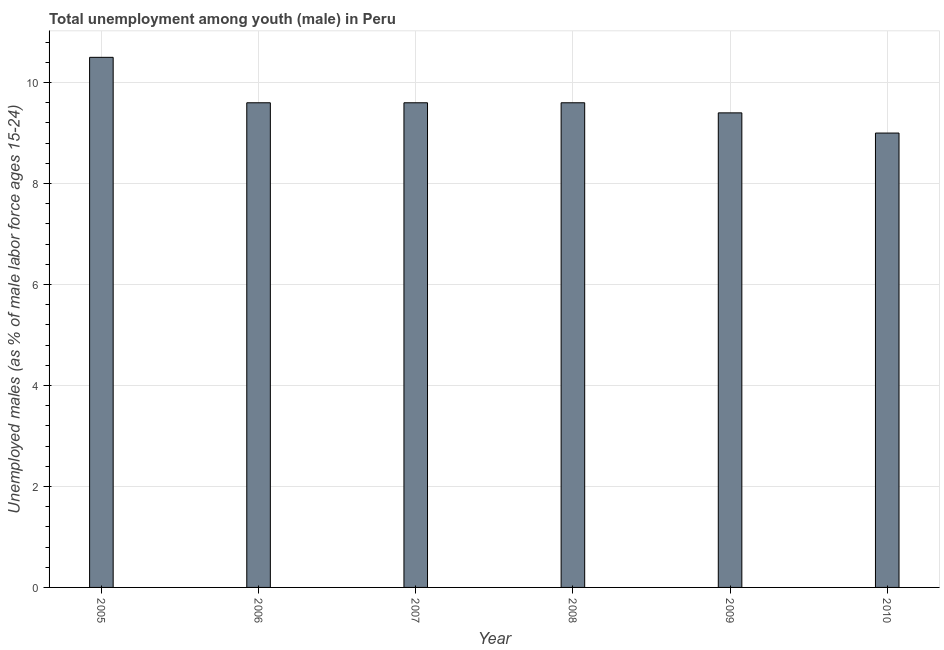Does the graph contain any zero values?
Give a very brief answer. No. What is the title of the graph?
Provide a short and direct response. Total unemployment among youth (male) in Peru. What is the label or title of the X-axis?
Ensure brevity in your answer.  Year. What is the label or title of the Y-axis?
Provide a short and direct response. Unemployed males (as % of male labor force ages 15-24). What is the unemployed male youth population in 2008?
Ensure brevity in your answer.  9.6. What is the sum of the unemployed male youth population?
Keep it short and to the point. 57.7. What is the difference between the unemployed male youth population in 2009 and 2010?
Give a very brief answer. 0.4. What is the average unemployed male youth population per year?
Your answer should be very brief. 9.62. What is the median unemployed male youth population?
Offer a very short reply. 9.6. In how many years, is the unemployed male youth population greater than 7.6 %?
Keep it short and to the point. 6. Do a majority of the years between 2008 and 2010 (inclusive) have unemployed male youth population greater than 2.4 %?
Your response must be concise. Yes. What is the ratio of the unemployed male youth population in 2005 to that in 2009?
Offer a terse response. 1.12. Is the difference between the unemployed male youth population in 2005 and 2009 greater than the difference between any two years?
Provide a short and direct response. No. Is the sum of the unemployed male youth population in 2005 and 2008 greater than the maximum unemployed male youth population across all years?
Offer a terse response. Yes. In how many years, is the unemployed male youth population greater than the average unemployed male youth population taken over all years?
Offer a very short reply. 1. How many bars are there?
Keep it short and to the point. 6. How many years are there in the graph?
Your answer should be very brief. 6. What is the difference between two consecutive major ticks on the Y-axis?
Make the answer very short. 2. Are the values on the major ticks of Y-axis written in scientific E-notation?
Offer a terse response. No. What is the Unemployed males (as % of male labor force ages 15-24) of 2005?
Your answer should be compact. 10.5. What is the Unemployed males (as % of male labor force ages 15-24) in 2006?
Your response must be concise. 9.6. What is the Unemployed males (as % of male labor force ages 15-24) of 2007?
Make the answer very short. 9.6. What is the Unemployed males (as % of male labor force ages 15-24) of 2008?
Offer a very short reply. 9.6. What is the Unemployed males (as % of male labor force ages 15-24) in 2009?
Give a very brief answer. 9.4. What is the difference between the Unemployed males (as % of male labor force ages 15-24) in 2005 and 2007?
Your answer should be very brief. 0.9. What is the difference between the Unemployed males (as % of male labor force ages 15-24) in 2005 and 2009?
Your answer should be very brief. 1.1. What is the difference between the Unemployed males (as % of male labor force ages 15-24) in 2006 and 2007?
Offer a very short reply. 0. What is the difference between the Unemployed males (as % of male labor force ages 15-24) in 2006 and 2008?
Give a very brief answer. 0. What is the difference between the Unemployed males (as % of male labor force ages 15-24) in 2006 and 2009?
Your answer should be compact. 0.2. What is the difference between the Unemployed males (as % of male labor force ages 15-24) in 2007 and 2008?
Offer a terse response. 0. What is the difference between the Unemployed males (as % of male labor force ages 15-24) in 2008 and 2009?
Give a very brief answer. 0.2. What is the difference between the Unemployed males (as % of male labor force ages 15-24) in 2008 and 2010?
Your answer should be very brief. 0.6. What is the difference between the Unemployed males (as % of male labor force ages 15-24) in 2009 and 2010?
Provide a short and direct response. 0.4. What is the ratio of the Unemployed males (as % of male labor force ages 15-24) in 2005 to that in 2006?
Make the answer very short. 1.09. What is the ratio of the Unemployed males (as % of male labor force ages 15-24) in 2005 to that in 2007?
Make the answer very short. 1.09. What is the ratio of the Unemployed males (as % of male labor force ages 15-24) in 2005 to that in 2008?
Offer a very short reply. 1.09. What is the ratio of the Unemployed males (as % of male labor force ages 15-24) in 2005 to that in 2009?
Your answer should be compact. 1.12. What is the ratio of the Unemployed males (as % of male labor force ages 15-24) in 2005 to that in 2010?
Keep it short and to the point. 1.17. What is the ratio of the Unemployed males (as % of male labor force ages 15-24) in 2006 to that in 2007?
Offer a very short reply. 1. What is the ratio of the Unemployed males (as % of male labor force ages 15-24) in 2006 to that in 2008?
Provide a succinct answer. 1. What is the ratio of the Unemployed males (as % of male labor force ages 15-24) in 2006 to that in 2009?
Your answer should be very brief. 1.02. What is the ratio of the Unemployed males (as % of male labor force ages 15-24) in 2006 to that in 2010?
Provide a short and direct response. 1.07. What is the ratio of the Unemployed males (as % of male labor force ages 15-24) in 2007 to that in 2009?
Give a very brief answer. 1.02. What is the ratio of the Unemployed males (as % of male labor force ages 15-24) in 2007 to that in 2010?
Offer a very short reply. 1.07. What is the ratio of the Unemployed males (as % of male labor force ages 15-24) in 2008 to that in 2010?
Offer a terse response. 1.07. What is the ratio of the Unemployed males (as % of male labor force ages 15-24) in 2009 to that in 2010?
Your response must be concise. 1.04. 